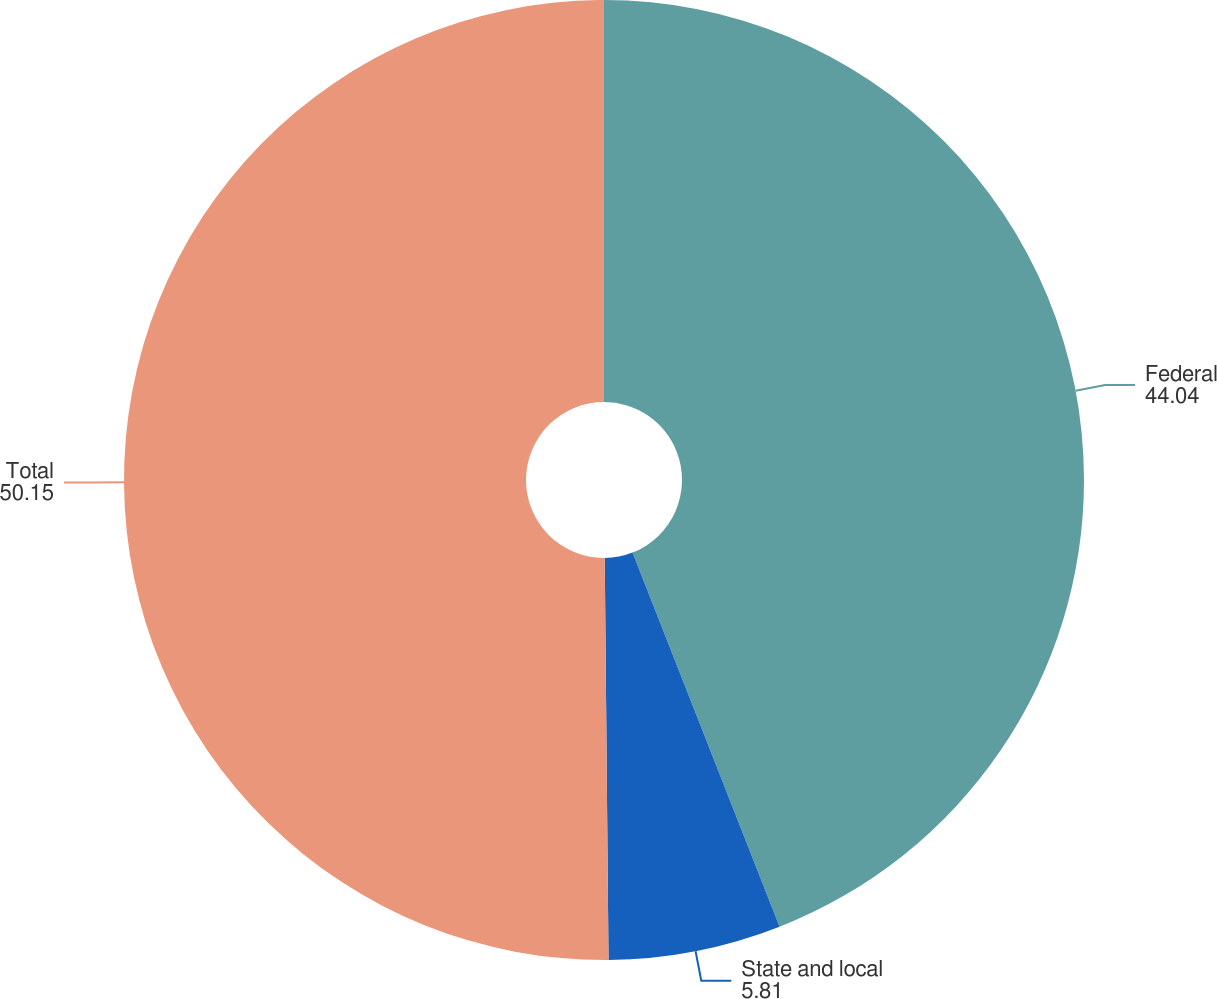Convert chart to OTSL. <chart><loc_0><loc_0><loc_500><loc_500><pie_chart><fcel>Federal<fcel>State and local<fcel>Total<nl><fcel>44.04%<fcel>5.81%<fcel>50.15%<nl></chart> 